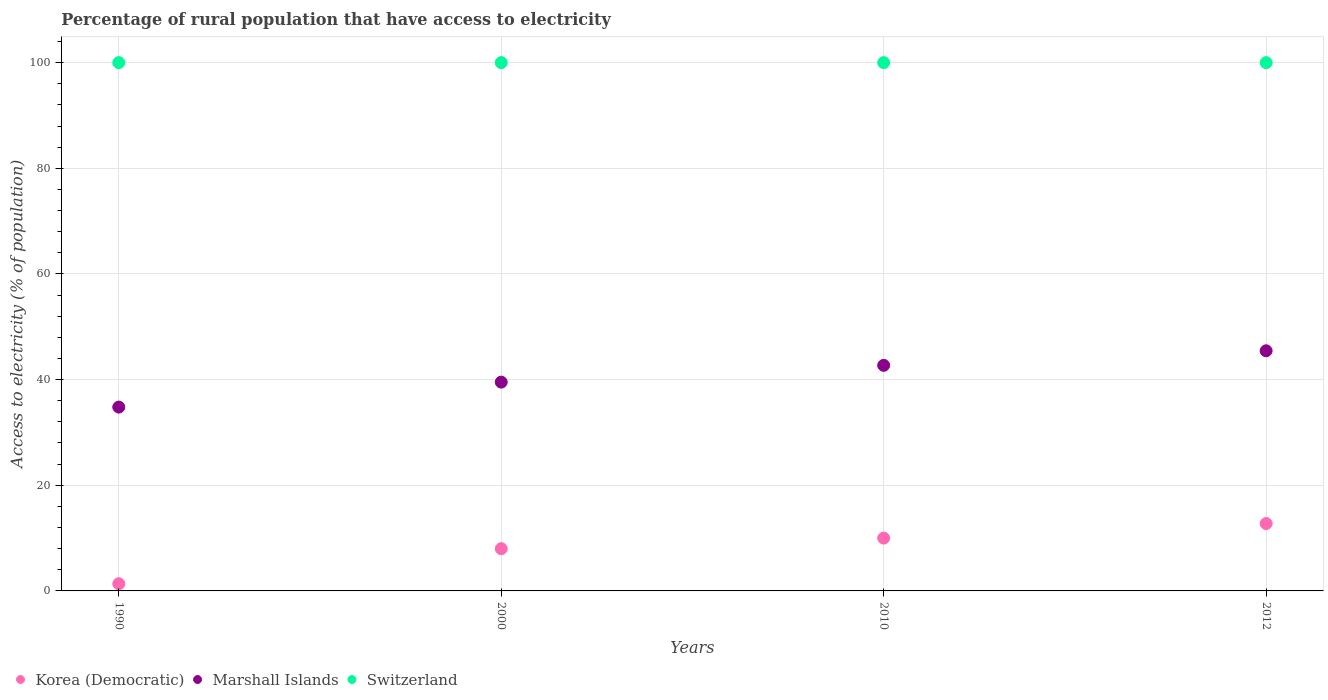What is the percentage of rural population that have access to electricity in Korea (Democratic) in 1990?
Your answer should be very brief. 1.36. Across all years, what is the maximum percentage of rural population that have access to electricity in Korea (Democratic)?
Provide a short and direct response. 12.75. Across all years, what is the minimum percentage of rural population that have access to electricity in Marshall Islands?
Your answer should be very brief. 34.8. What is the total percentage of rural population that have access to electricity in Marshall Islands in the graph?
Offer a very short reply. 162.47. What is the difference between the percentage of rural population that have access to electricity in Marshall Islands in 2000 and that in 2012?
Offer a terse response. -5.93. What is the difference between the percentage of rural population that have access to electricity in Korea (Democratic) in 2012 and the percentage of rural population that have access to electricity in Switzerland in 2010?
Ensure brevity in your answer.  -87.25. In the year 2012, what is the difference between the percentage of rural population that have access to electricity in Marshall Islands and percentage of rural population that have access to electricity in Switzerland?
Give a very brief answer. -54.55. What is the ratio of the percentage of rural population that have access to electricity in Korea (Democratic) in 1990 to that in 2012?
Keep it short and to the point. 0.11. What is the difference between the highest and the second highest percentage of rural population that have access to electricity in Korea (Democratic)?
Your answer should be compact. 2.75. What is the difference between the highest and the lowest percentage of rural population that have access to electricity in Korea (Democratic)?
Your response must be concise. 11.39. Does the percentage of rural population that have access to electricity in Switzerland monotonically increase over the years?
Offer a very short reply. No. Is the percentage of rural population that have access to electricity in Korea (Democratic) strictly greater than the percentage of rural population that have access to electricity in Switzerland over the years?
Your answer should be very brief. No. Is the percentage of rural population that have access to electricity in Switzerland strictly less than the percentage of rural population that have access to electricity in Korea (Democratic) over the years?
Your response must be concise. No. How many dotlines are there?
Offer a terse response. 3. What is the difference between two consecutive major ticks on the Y-axis?
Offer a very short reply. 20. Does the graph contain any zero values?
Your answer should be compact. No. Where does the legend appear in the graph?
Offer a terse response. Bottom left. How many legend labels are there?
Give a very brief answer. 3. What is the title of the graph?
Your answer should be very brief. Percentage of rural population that have access to electricity. Does "Nepal" appear as one of the legend labels in the graph?
Provide a succinct answer. No. What is the label or title of the Y-axis?
Ensure brevity in your answer.  Access to electricity (% of population). What is the Access to electricity (% of population) of Korea (Democratic) in 1990?
Offer a terse response. 1.36. What is the Access to electricity (% of population) in Marshall Islands in 1990?
Give a very brief answer. 34.8. What is the Access to electricity (% of population) in Switzerland in 1990?
Offer a very short reply. 100. What is the Access to electricity (% of population) of Marshall Islands in 2000?
Provide a succinct answer. 39.52. What is the Access to electricity (% of population) of Korea (Democratic) in 2010?
Give a very brief answer. 10. What is the Access to electricity (% of population) in Marshall Islands in 2010?
Your answer should be compact. 42.7. What is the Access to electricity (% of population) of Switzerland in 2010?
Your answer should be very brief. 100. What is the Access to electricity (% of population) of Korea (Democratic) in 2012?
Offer a terse response. 12.75. What is the Access to electricity (% of population) in Marshall Islands in 2012?
Offer a terse response. 45.45. Across all years, what is the maximum Access to electricity (% of population) in Korea (Democratic)?
Make the answer very short. 12.75. Across all years, what is the maximum Access to electricity (% of population) in Marshall Islands?
Make the answer very short. 45.45. Across all years, what is the minimum Access to electricity (% of population) of Korea (Democratic)?
Provide a succinct answer. 1.36. Across all years, what is the minimum Access to electricity (% of population) in Marshall Islands?
Ensure brevity in your answer.  34.8. What is the total Access to electricity (% of population) in Korea (Democratic) in the graph?
Make the answer very short. 32.11. What is the total Access to electricity (% of population) of Marshall Islands in the graph?
Your response must be concise. 162.47. What is the difference between the Access to electricity (% of population) of Korea (Democratic) in 1990 and that in 2000?
Provide a succinct answer. -6.64. What is the difference between the Access to electricity (% of population) of Marshall Islands in 1990 and that in 2000?
Provide a short and direct response. -4.72. What is the difference between the Access to electricity (% of population) of Korea (Democratic) in 1990 and that in 2010?
Offer a terse response. -8.64. What is the difference between the Access to electricity (% of population) of Marshall Islands in 1990 and that in 2010?
Offer a very short reply. -7.9. What is the difference between the Access to electricity (% of population) of Switzerland in 1990 and that in 2010?
Offer a very short reply. 0. What is the difference between the Access to electricity (% of population) in Korea (Democratic) in 1990 and that in 2012?
Give a very brief answer. -11.39. What is the difference between the Access to electricity (% of population) of Marshall Islands in 1990 and that in 2012?
Your answer should be very brief. -10.66. What is the difference between the Access to electricity (% of population) of Korea (Democratic) in 2000 and that in 2010?
Provide a short and direct response. -2. What is the difference between the Access to electricity (% of population) of Marshall Islands in 2000 and that in 2010?
Provide a short and direct response. -3.18. What is the difference between the Access to electricity (% of population) in Switzerland in 2000 and that in 2010?
Provide a short and direct response. 0. What is the difference between the Access to electricity (% of population) in Korea (Democratic) in 2000 and that in 2012?
Provide a short and direct response. -4.75. What is the difference between the Access to electricity (% of population) in Marshall Islands in 2000 and that in 2012?
Provide a succinct answer. -5.93. What is the difference between the Access to electricity (% of population) in Korea (Democratic) in 2010 and that in 2012?
Offer a very short reply. -2.75. What is the difference between the Access to electricity (% of population) in Marshall Islands in 2010 and that in 2012?
Provide a succinct answer. -2.75. What is the difference between the Access to electricity (% of population) in Switzerland in 2010 and that in 2012?
Keep it short and to the point. 0. What is the difference between the Access to electricity (% of population) in Korea (Democratic) in 1990 and the Access to electricity (% of population) in Marshall Islands in 2000?
Offer a terse response. -38.16. What is the difference between the Access to electricity (% of population) of Korea (Democratic) in 1990 and the Access to electricity (% of population) of Switzerland in 2000?
Provide a succinct answer. -98.64. What is the difference between the Access to electricity (% of population) of Marshall Islands in 1990 and the Access to electricity (% of population) of Switzerland in 2000?
Give a very brief answer. -65.2. What is the difference between the Access to electricity (% of population) in Korea (Democratic) in 1990 and the Access to electricity (% of population) in Marshall Islands in 2010?
Make the answer very short. -41.34. What is the difference between the Access to electricity (% of population) of Korea (Democratic) in 1990 and the Access to electricity (% of population) of Switzerland in 2010?
Give a very brief answer. -98.64. What is the difference between the Access to electricity (% of population) of Marshall Islands in 1990 and the Access to electricity (% of population) of Switzerland in 2010?
Your answer should be very brief. -65.2. What is the difference between the Access to electricity (% of population) of Korea (Democratic) in 1990 and the Access to electricity (% of population) of Marshall Islands in 2012?
Your response must be concise. -44.09. What is the difference between the Access to electricity (% of population) of Korea (Democratic) in 1990 and the Access to electricity (% of population) of Switzerland in 2012?
Your answer should be very brief. -98.64. What is the difference between the Access to electricity (% of population) of Marshall Islands in 1990 and the Access to electricity (% of population) of Switzerland in 2012?
Ensure brevity in your answer.  -65.2. What is the difference between the Access to electricity (% of population) of Korea (Democratic) in 2000 and the Access to electricity (% of population) of Marshall Islands in 2010?
Keep it short and to the point. -34.7. What is the difference between the Access to electricity (% of population) of Korea (Democratic) in 2000 and the Access to electricity (% of population) of Switzerland in 2010?
Give a very brief answer. -92. What is the difference between the Access to electricity (% of population) in Marshall Islands in 2000 and the Access to electricity (% of population) in Switzerland in 2010?
Provide a short and direct response. -60.48. What is the difference between the Access to electricity (% of population) in Korea (Democratic) in 2000 and the Access to electricity (% of population) in Marshall Islands in 2012?
Provide a short and direct response. -37.45. What is the difference between the Access to electricity (% of population) of Korea (Democratic) in 2000 and the Access to electricity (% of population) of Switzerland in 2012?
Provide a short and direct response. -92. What is the difference between the Access to electricity (% of population) of Marshall Islands in 2000 and the Access to electricity (% of population) of Switzerland in 2012?
Make the answer very short. -60.48. What is the difference between the Access to electricity (% of population) in Korea (Democratic) in 2010 and the Access to electricity (% of population) in Marshall Islands in 2012?
Your answer should be compact. -35.45. What is the difference between the Access to electricity (% of population) of Korea (Democratic) in 2010 and the Access to electricity (% of population) of Switzerland in 2012?
Provide a succinct answer. -90. What is the difference between the Access to electricity (% of population) of Marshall Islands in 2010 and the Access to electricity (% of population) of Switzerland in 2012?
Ensure brevity in your answer.  -57.3. What is the average Access to electricity (% of population) of Korea (Democratic) per year?
Offer a terse response. 8.03. What is the average Access to electricity (% of population) in Marshall Islands per year?
Offer a terse response. 40.62. In the year 1990, what is the difference between the Access to electricity (% of population) of Korea (Democratic) and Access to electricity (% of population) of Marshall Islands?
Offer a very short reply. -33.44. In the year 1990, what is the difference between the Access to electricity (% of population) of Korea (Democratic) and Access to electricity (% of population) of Switzerland?
Provide a succinct answer. -98.64. In the year 1990, what is the difference between the Access to electricity (% of population) of Marshall Islands and Access to electricity (% of population) of Switzerland?
Your answer should be very brief. -65.2. In the year 2000, what is the difference between the Access to electricity (% of population) in Korea (Democratic) and Access to electricity (% of population) in Marshall Islands?
Your answer should be very brief. -31.52. In the year 2000, what is the difference between the Access to electricity (% of population) in Korea (Democratic) and Access to electricity (% of population) in Switzerland?
Your answer should be very brief. -92. In the year 2000, what is the difference between the Access to electricity (% of population) of Marshall Islands and Access to electricity (% of population) of Switzerland?
Offer a terse response. -60.48. In the year 2010, what is the difference between the Access to electricity (% of population) of Korea (Democratic) and Access to electricity (% of population) of Marshall Islands?
Offer a terse response. -32.7. In the year 2010, what is the difference between the Access to electricity (% of population) in Korea (Democratic) and Access to electricity (% of population) in Switzerland?
Offer a terse response. -90. In the year 2010, what is the difference between the Access to electricity (% of population) of Marshall Islands and Access to electricity (% of population) of Switzerland?
Provide a short and direct response. -57.3. In the year 2012, what is the difference between the Access to electricity (% of population) in Korea (Democratic) and Access to electricity (% of population) in Marshall Islands?
Give a very brief answer. -32.7. In the year 2012, what is the difference between the Access to electricity (% of population) in Korea (Democratic) and Access to electricity (% of population) in Switzerland?
Make the answer very short. -87.25. In the year 2012, what is the difference between the Access to electricity (% of population) in Marshall Islands and Access to electricity (% of population) in Switzerland?
Provide a short and direct response. -54.55. What is the ratio of the Access to electricity (% of population) of Korea (Democratic) in 1990 to that in 2000?
Provide a short and direct response. 0.17. What is the ratio of the Access to electricity (% of population) in Marshall Islands in 1990 to that in 2000?
Provide a short and direct response. 0.88. What is the ratio of the Access to electricity (% of population) in Switzerland in 1990 to that in 2000?
Ensure brevity in your answer.  1. What is the ratio of the Access to electricity (% of population) of Korea (Democratic) in 1990 to that in 2010?
Keep it short and to the point. 0.14. What is the ratio of the Access to electricity (% of population) of Marshall Islands in 1990 to that in 2010?
Offer a terse response. 0.81. What is the ratio of the Access to electricity (% of population) of Switzerland in 1990 to that in 2010?
Offer a terse response. 1. What is the ratio of the Access to electricity (% of population) in Korea (Democratic) in 1990 to that in 2012?
Offer a very short reply. 0.11. What is the ratio of the Access to electricity (% of population) in Marshall Islands in 1990 to that in 2012?
Offer a terse response. 0.77. What is the ratio of the Access to electricity (% of population) in Switzerland in 1990 to that in 2012?
Your answer should be very brief. 1. What is the ratio of the Access to electricity (% of population) in Korea (Democratic) in 2000 to that in 2010?
Make the answer very short. 0.8. What is the ratio of the Access to electricity (% of population) in Marshall Islands in 2000 to that in 2010?
Offer a terse response. 0.93. What is the ratio of the Access to electricity (% of population) in Switzerland in 2000 to that in 2010?
Offer a very short reply. 1. What is the ratio of the Access to electricity (% of population) in Korea (Democratic) in 2000 to that in 2012?
Your answer should be very brief. 0.63. What is the ratio of the Access to electricity (% of population) in Marshall Islands in 2000 to that in 2012?
Provide a succinct answer. 0.87. What is the ratio of the Access to electricity (% of population) of Switzerland in 2000 to that in 2012?
Your answer should be very brief. 1. What is the ratio of the Access to electricity (% of population) in Korea (Democratic) in 2010 to that in 2012?
Keep it short and to the point. 0.78. What is the ratio of the Access to electricity (% of population) in Marshall Islands in 2010 to that in 2012?
Provide a short and direct response. 0.94. What is the difference between the highest and the second highest Access to electricity (% of population) of Korea (Democratic)?
Give a very brief answer. 2.75. What is the difference between the highest and the second highest Access to electricity (% of population) in Marshall Islands?
Ensure brevity in your answer.  2.75. What is the difference between the highest and the lowest Access to electricity (% of population) in Korea (Democratic)?
Provide a short and direct response. 11.39. What is the difference between the highest and the lowest Access to electricity (% of population) of Marshall Islands?
Make the answer very short. 10.66. 